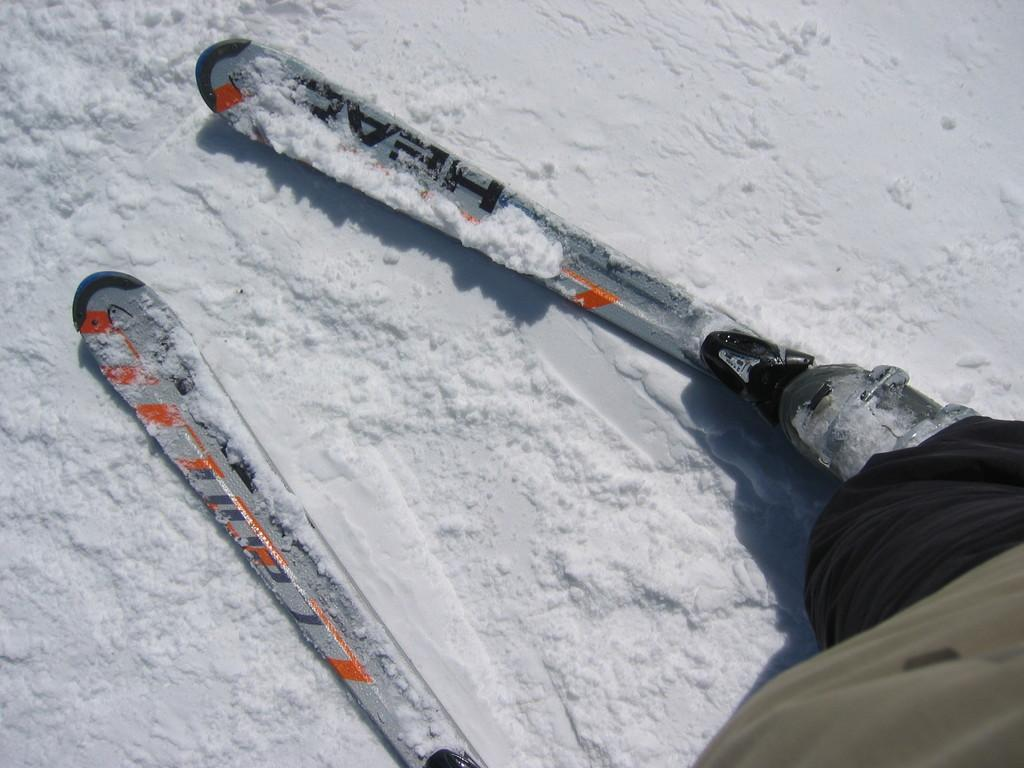What is the main subject of the image? There is a person in the image. What is the person wearing on their legs? The person's legs are wearing skis. Where is the person standing in the image? The person is standing on the ice. What is the person's digestion like in the image? There is no information about the person's digestion in the image. Does the image prove the existence of the person? The image does not prove the existence of the person, but it does provide visual evidence of their presence. 